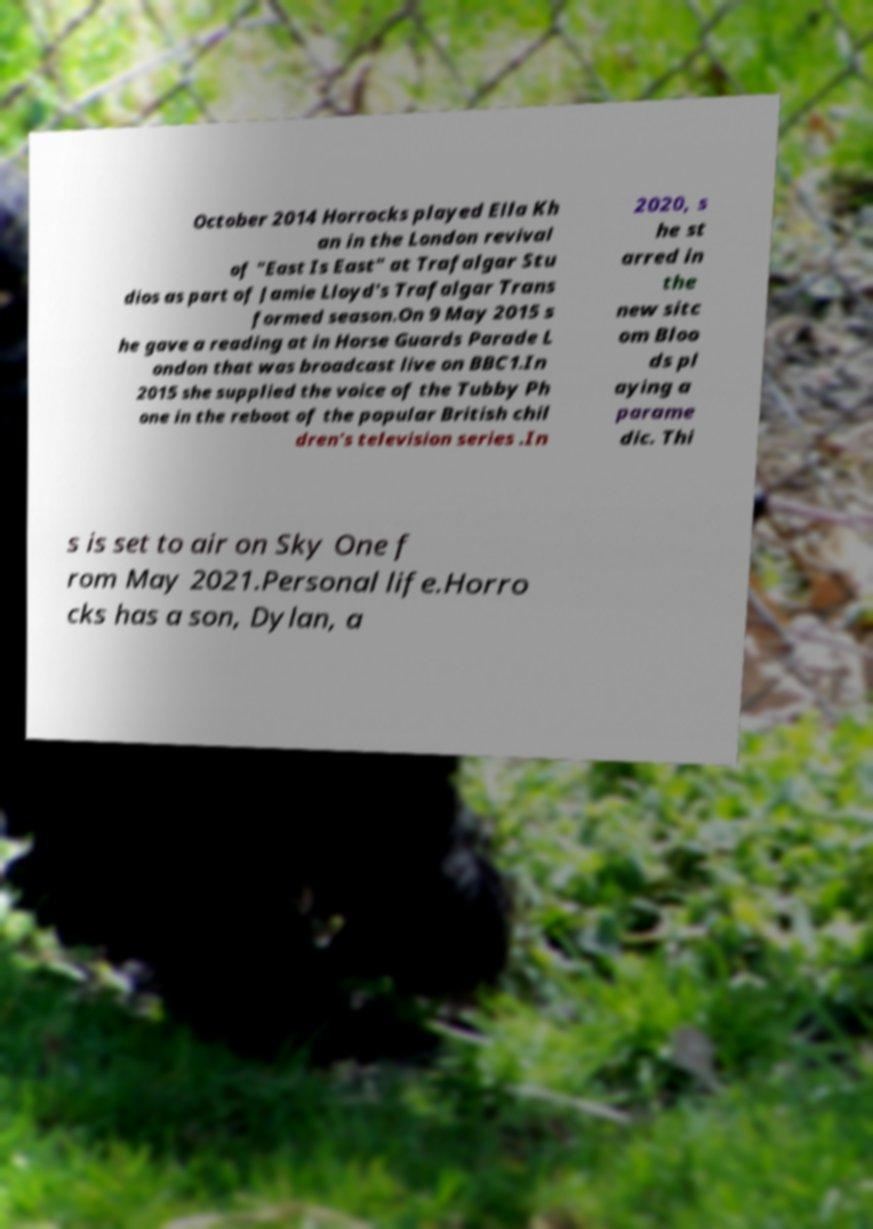Please identify and transcribe the text found in this image. October 2014 Horrocks played Ella Kh an in the London revival of "East Is East" at Trafalgar Stu dios as part of Jamie Lloyd's Trafalgar Trans formed season.On 9 May 2015 s he gave a reading at in Horse Guards Parade L ondon that was broadcast live on BBC1.In 2015 she supplied the voice of the Tubby Ph one in the reboot of the popular British chil dren's television series .In 2020, s he st arred in the new sitc om Bloo ds pl aying a parame dic. Thi s is set to air on Sky One f rom May 2021.Personal life.Horro cks has a son, Dylan, a 